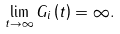Convert formula to latex. <formula><loc_0><loc_0><loc_500><loc_500>\lim _ { t \rightarrow \infty } G _ { i } \left ( t \right ) = \infty .</formula> 